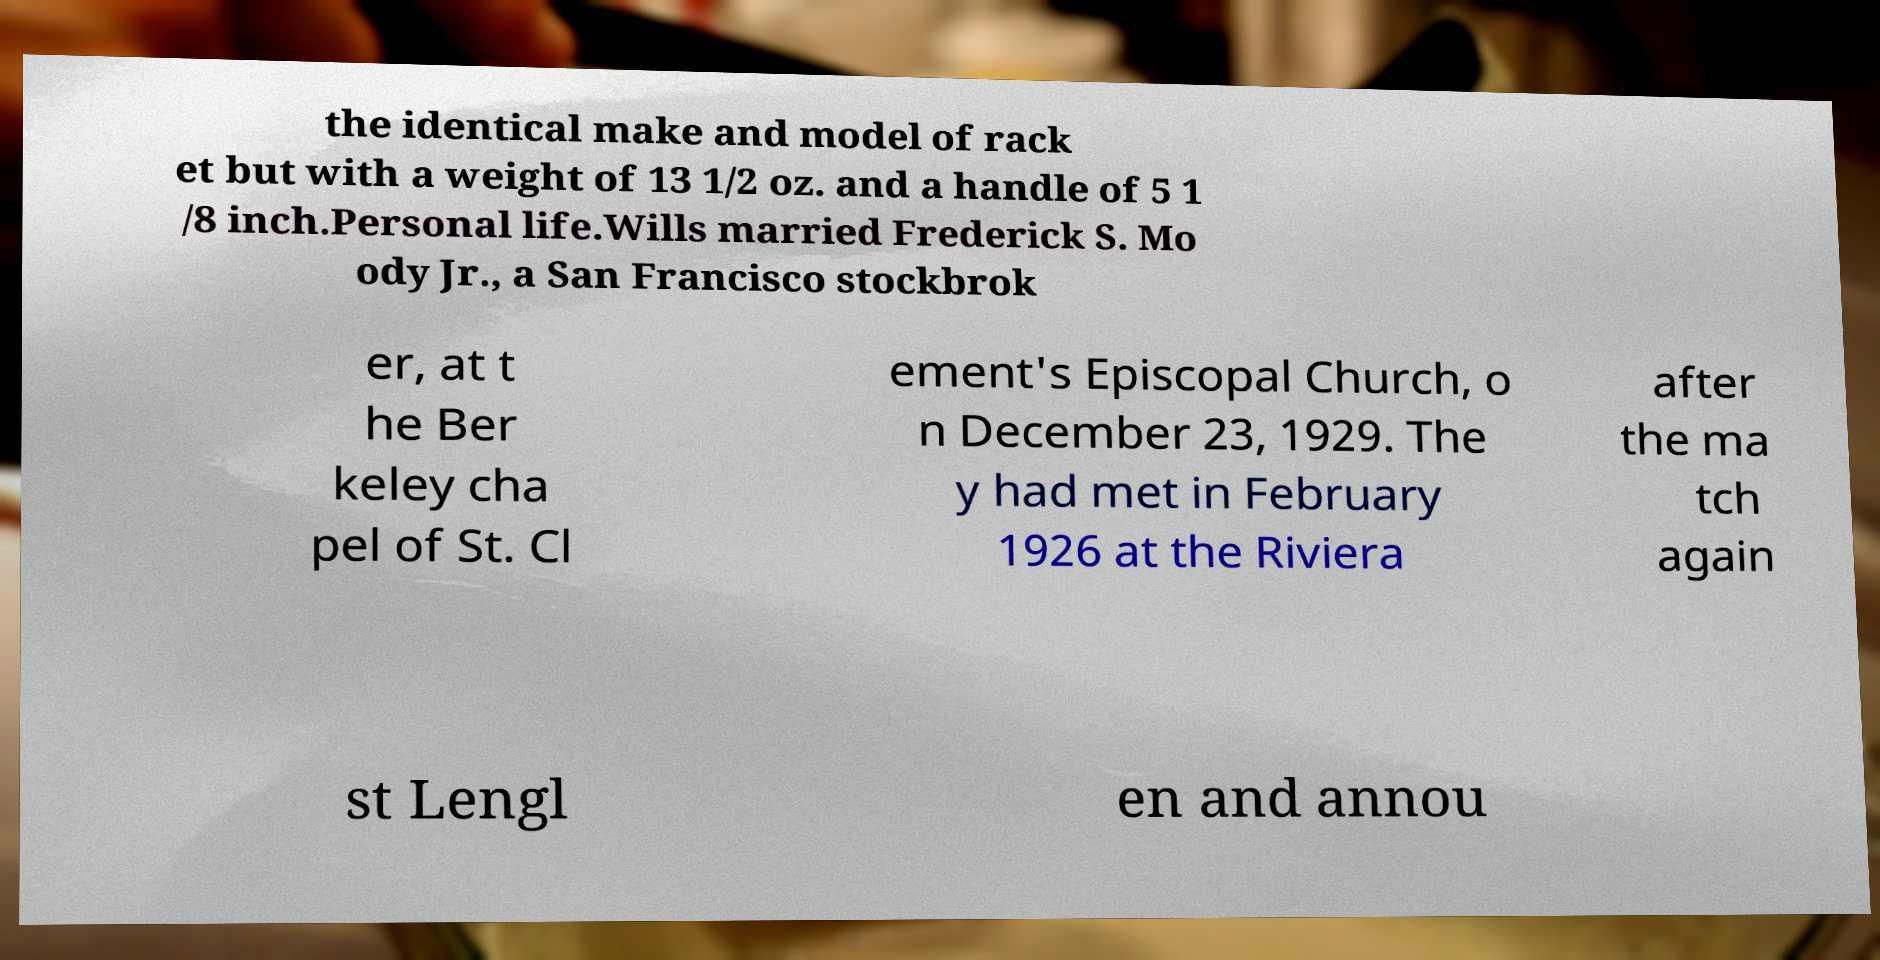Can you accurately transcribe the text from the provided image for me? the identical make and model of rack et but with a weight of 13 1/2 oz. and a handle of 5 1 /8 inch.Personal life.Wills married Frederick S. Mo ody Jr., a San Francisco stockbrok er, at t he Ber keley cha pel of St. Cl ement's Episcopal Church, o n December 23, 1929. The y had met in February 1926 at the Riviera after the ma tch again st Lengl en and annou 